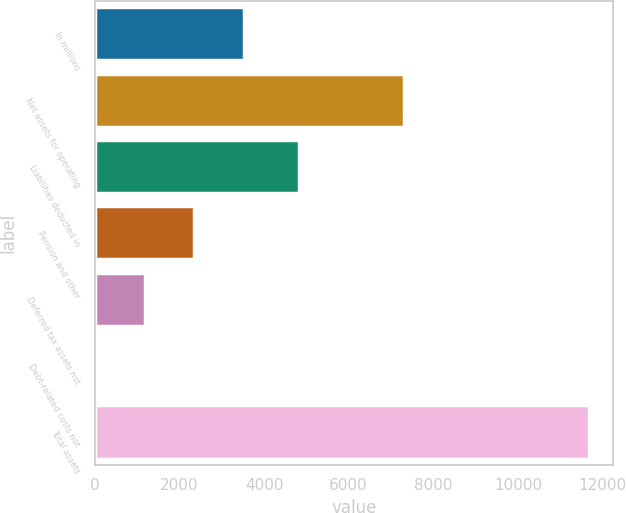<chart> <loc_0><loc_0><loc_500><loc_500><bar_chart><fcel>In millions<fcel>Net assets for operating<fcel>Liabilities deducted in<fcel>Pension and other<fcel>Deferred tax assets not<fcel>Debt-related costs not<fcel>Total assets<nl><fcel>3517.9<fcel>7304<fcel>4832<fcel>2353.6<fcel>1189.3<fcel>25<fcel>11668<nl></chart> 